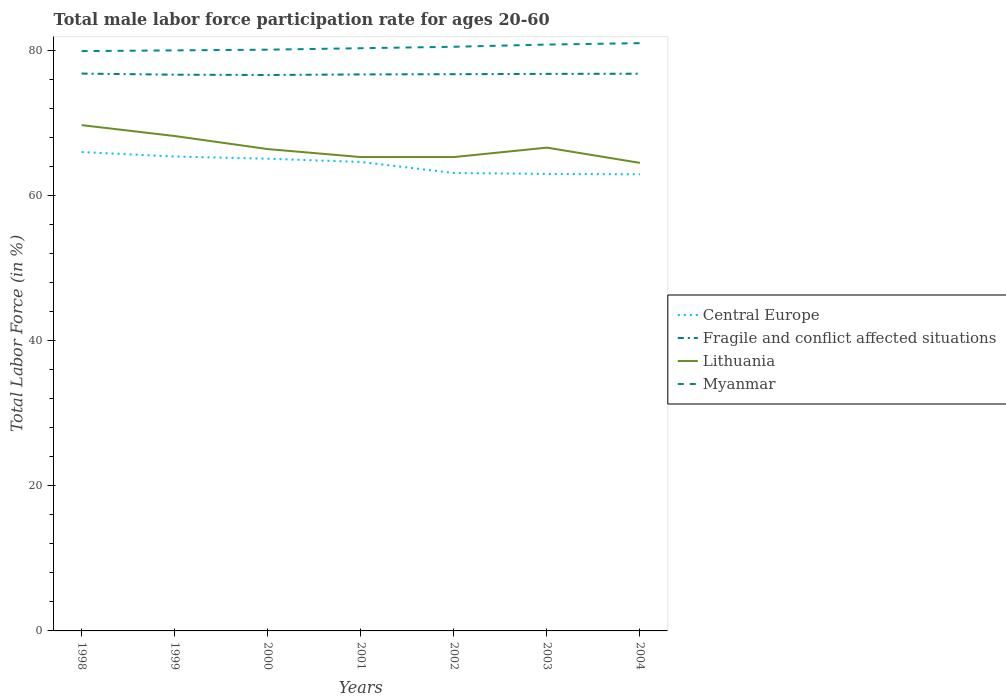Does the line corresponding to Myanmar intersect with the line corresponding to Lithuania?
Make the answer very short. No. Is the number of lines equal to the number of legend labels?
Provide a succinct answer. Yes. Across all years, what is the maximum male labor force participation rate in Lithuania?
Offer a terse response. 64.5. In which year was the male labor force participation rate in Lithuania maximum?
Your answer should be very brief. 2004. What is the total male labor force participation rate in Central Europe in the graph?
Ensure brevity in your answer.  0.75. What is the difference between the highest and the second highest male labor force participation rate in Lithuania?
Make the answer very short. 5.2. What is the difference between the highest and the lowest male labor force participation rate in Fragile and conflict affected situations?
Your response must be concise. 4. Are the values on the major ticks of Y-axis written in scientific E-notation?
Your answer should be very brief. No. Does the graph contain any zero values?
Provide a succinct answer. No. Does the graph contain grids?
Ensure brevity in your answer.  No. Where does the legend appear in the graph?
Provide a short and direct response. Center right. How many legend labels are there?
Your answer should be compact. 4. What is the title of the graph?
Offer a very short reply. Total male labor force participation rate for ages 20-60. What is the label or title of the X-axis?
Offer a terse response. Years. What is the label or title of the Y-axis?
Your response must be concise. Total Labor Force (in %). What is the Total Labor Force (in %) of Central Europe in 1998?
Provide a short and direct response. 65.99. What is the Total Labor Force (in %) of Fragile and conflict affected situations in 1998?
Offer a very short reply. 76.81. What is the Total Labor Force (in %) in Lithuania in 1998?
Keep it short and to the point. 69.7. What is the Total Labor Force (in %) in Myanmar in 1998?
Your answer should be compact. 79.9. What is the Total Labor Force (in %) of Central Europe in 1999?
Your answer should be compact. 65.37. What is the Total Labor Force (in %) of Fragile and conflict affected situations in 1999?
Make the answer very short. 76.65. What is the Total Labor Force (in %) in Lithuania in 1999?
Your response must be concise. 68.2. What is the Total Labor Force (in %) in Central Europe in 2000?
Your answer should be very brief. 65.07. What is the Total Labor Force (in %) in Fragile and conflict affected situations in 2000?
Provide a succinct answer. 76.61. What is the Total Labor Force (in %) of Lithuania in 2000?
Your response must be concise. 66.4. What is the Total Labor Force (in %) of Myanmar in 2000?
Your response must be concise. 80.1. What is the Total Labor Force (in %) of Central Europe in 2001?
Provide a short and direct response. 64.62. What is the Total Labor Force (in %) in Fragile and conflict affected situations in 2001?
Ensure brevity in your answer.  76.69. What is the Total Labor Force (in %) in Lithuania in 2001?
Make the answer very short. 65.3. What is the Total Labor Force (in %) in Myanmar in 2001?
Give a very brief answer. 80.3. What is the Total Labor Force (in %) of Central Europe in 2002?
Provide a succinct answer. 63.11. What is the Total Labor Force (in %) of Fragile and conflict affected situations in 2002?
Offer a very short reply. 76.72. What is the Total Labor Force (in %) of Lithuania in 2002?
Your answer should be compact. 65.3. What is the Total Labor Force (in %) in Myanmar in 2002?
Ensure brevity in your answer.  80.5. What is the Total Labor Force (in %) in Central Europe in 2003?
Offer a very short reply. 62.97. What is the Total Labor Force (in %) in Fragile and conflict affected situations in 2003?
Offer a very short reply. 76.76. What is the Total Labor Force (in %) of Lithuania in 2003?
Offer a very short reply. 66.6. What is the Total Labor Force (in %) of Myanmar in 2003?
Offer a very short reply. 80.8. What is the Total Labor Force (in %) in Central Europe in 2004?
Offer a very short reply. 62.93. What is the Total Labor Force (in %) of Fragile and conflict affected situations in 2004?
Your answer should be compact. 76.79. What is the Total Labor Force (in %) of Lithuania in 2004?
Your response must be concise. 64.5. What is the Total Labor Force (in %) of Myanmar in 2004?
Provide a succinct answer. 81. Across all years, what is the maximum Total Labor Force (in %) in Central Europe?
Provide a succinct answer. 65.99. Across all years, what is the maximum Total Labor Force (in %) of Fragile and conflict affected situations?
Your answer should be compact. 76.81. Across all years, what is the maximum Total Labor Force (in %) in Lithuania?
Provide a succinct answer. 69.7. Across all years, what is the maximum Total Labor Force (in %) in Myanmar?
Provide a succinct answer. 81. Across all years, what is the minimum Total Labor Force (in %) in Central Europe?
Offer a terse response. 62.93. Across all years, what is the minimum Total Labor Force (in %) of Fragile and conflict affected situations?
Provide a short and direct response. 76.61. Across all years, what is the minimum Total Labor Force (in %) in Lithuania?
Your answer should be compact. 64.5. Across all years, what is the minimum Total Labor Force (in %) in Myanmar?
Your answer should be very brief. 79.9. What is the total Total Labor Force (in %) of Central Europe in the graph?
Your answer should be compact. 450.07. What is the total Total Labor Force (in %) of Fragile and conflict affected situations in the graph?
Offer a very short reply. 537.03. What is the total Total Labor Force (in %) in Lithuania in the graph?
Provide a succinct answer. 466. What is the total Total Labor Force (in %) in Myanmar in the graph?
Provide a short and direct response. 562.6. What is the difference between the Total Labor Force (in %) of Central Europe in 1998 and that in 1999?
Offer a very short reply. 0.62. What is the difference between the Total Labor Force (in %) of Fragile and conflict affected situations in 1998 and that in 1999?
Offer a terse response. 0.16. What is the difference between the Total Labor Force (in %) in Lithuania in 1998 and that in 1999?
Keep it short and to the point. 1.5. What is the difference between the Total Labor Force (in %) in Central Europe in 1998 and that in 2000?
Make the answer very short. 0.92. What is the difference between the Total Labor Force (in %) of Fragile and conflict affected situations in 1998 and that in 2000?
Keep it short and to the point. 0.2. What is the difference between the Total Labor Force (in %) of Myanmar in 1998 and that in 2000?
Give a very brief answer. -0.2. What is the difference between the Total Labor Force (in %) in Central Europe in 1998 and that in 2001?
Make the answer very short. 1.37. What is the difference between the Total Labor Force (in %) in Fragile and conflict affected situations in 1998 and that in 2001?
Ensure brevity in your answer.  0.12. What is the difference between the Total Labor Force (in %) in Myanmar in 1998 and that in 2001?
Give a very brief answer. -0.4. What is the difference between the Total Labor Force (in %) of Central Europe in 1998 and that in 2002?
Provide a short and direct response. 2.89. What is the difference between the Total Labor Force (in %) in Fragile and conflict affected situations in 1998 and that in 2002?
Keep it short and to the point. 0.09. What is the difference between the Total Labor Force (in %) in Lithuania in 1998 and that in 2002?
Keep it short and to the point. 4.4. What is the difference between the Total Labor Force (in %) of Myanmar in 1998 and that in 2002?
Provide a succinct answer. -0.6. What is the difference between the Total Labor Force (in %) of Central Europe in 1998 and that in 2003?
Provide a short and direct response. 3.02. What is the difference between the Total Labor Force (in %) of Fragile and conflict affected situations in 1998 and that in 2003?
Your answer should be very brief. 0.04. What is the difference between the Total Labor Force (in %) of Lithuania in 1998 and that in 2003?
Give a very brief answer. 3.1. What is the difference between the Total Labor Force (in %) of Myanmar in 1998 and that in 2003?
Keep it short and to the point. -0.9. What is the difference between the Total Labor Force (in %) of Central Europe in 1998 and that in 2004?
Provide a short and direct response. 3.07. What is the difference between the Total Labor Force (in %) in Fragile and conflict affected situations in 1998 and that in 2004?
Provide a succinct answer. 0.02. What is the difference between the Total Labor Force (in %) of Lithuania in 1998 and that in 2004?
Give a very brief answer. 5.2. What is the difference between the Total Labor Force (in %) of Myanmar in 1998 and that in 2004?
Your answer should be compact. -1.1. What is the difference between the Total Labor Force (in %) in Central Europe in 1999 and that in 2000?
Offer a very short reply. 0.3. What is the difference between the Total Labor Force (in %) in Fragile and conflict affected situations in 1999 and that in 2000?
Keep it short and to the point. 0.04. What is the difference between the Total Labor Force (in %) in Lithuania in 1999 and that in 2000?
Ensure brevity in your answer.  1.8. What is the difference between the Total Labor Force (in %) in Central Europe in 1999 and that in 2001?
Your answer should be compact. 0.75. What is the difference between the Total Labor Force (in %) in Fragile and conflict affected situations in 1999 and that in 2001?
Make the answer very short. -0.04. What is the difference between the Total Labor Force (in %) in Central Europe in 1999 and that in 2002?
Provide a succinct answer. 2.27. What is the difference between the Total Labor Force (in %) in Fragile and conflict affected situations in 1999 and that in 2002?
Keep it short and to the point. -0.07. What is the difference between the Total Labor Force (in %) in Central Europe in 1999 and that in 2003?
Give a very brief answer. 2.4. What is the difference between the Total Labor Force (in %) in Fragile and conflict affected situations in 1999 and that in 2003?
Give a very brief answer. -0.11. What is the difference between the Total Labor Force (in %) of Lithuania in 1999 and that in 2003?
Give a very brief answer. 1.6. What is the difference between the Total Labor Force (in %) in Central Europe in 1999 and that in 2004?
Make the answer very short. 2.45. What is the difference between the Total Labor Force (in %) of Fragile and conflict affected situations in 1999 and that in 2004?
Your response must be concise. -0.14. What is the difference between the Total Labor Force (in %) of Myanmar in 1999 and that in 2004?
Provide a short and direct response. -1. What is the difference between the Total Labor Force (in %) in Central Europe in 2000 and that in 2001?
Your answer should be very brief. 0.45. What is the difference between the Total Labor Force (in %) in Fragile and conflict affected situations in 2000 and that in 2001?
Keep it short and to the point. -0.08. What is the difference between the Total Labor Force (in %) in Central Europe in 2000 and that in 2002?
Provide a short and direct response. 1.97. What is the difference between the Total Labor Force (in %) in Fragile and conflict affected situations in 2000 and that in 2002?
Your answer should be compact. -0.11. What is the difference between the Total Labor Force (in %) in Lithuania in 2000 and that in 2002?
Offer a terse response. 1.1. What is the difference between the Total Labor Force (in %) in Myanmar in 2000 and that in 2002?
Offer a terse response. -0.4. What is the difference between the Total Labor Force (in %) in Central Europe in 2000 and that in 2003?
Give a very brief answer. 2.1. What is the difference between the Total Labor Force (in %) in Fragile and conflict affected situations in 2000 and that in 2003?
Offer a very short reply. -0.15. What is the difference between the Total Labor Force (in %) of Lithuania in 2000 and that in 2003?
Offer a terse response. -0.2. What is the difference between the Total Labor Force (in %) of Central Europe in 2000 and that in 2004?
Make the answer very short. 2.15. What is the difference between the Total Labor Force (in %) in Fragile and conflict affected situations in 2000 and that in 2004?
Keep it short and to the point. -0.18. What is the difference between the Total Labor Force (in %) in Central Europe in 2001 and that in 2002?
Keep it short and to the point. 1.52. What is the difference between the Total Labor Force (in %) in Fragile and conflict affected situations in 2001 and that in 2002?
Your response must be concise. -0.03. What is the difference between the Total Labor Force (in %) of Myanmar in 2001 and that in 2002?
Your response must be concise. -0.2. What is the difference between the Total Labor Force (in %) in Central Europe in 2001 and that in 2003?
Offer a very short reply. 1.65. What is the difference between the Total Labor Force (in %) of Fragile and conflict affected situations in 2001 and that in 2003?
Your answer should be compact. -0.08. What is the difference between the Total Labor Force (in %) of Lithuania in 2001 and that in 2003?
Your answer should be very brief. -1.3. What is the difference between the Total Labor Force (in %) of Myanmar in 2001 and that in 2003?
Keep it short and to the point. -0.5. What is the difference between the Total Labor Force (in %) in Central Europe in 2001 and that in 2004?
Keep it short and to the point. 1.7. What is the difference between the Total Labor Force (in %) of Fragile and conflict affected situations in 2001 and that in 2004?
Keep it short and to the point. -0.1. What is the difference between the Total Labor Force (in %) in Lithuania in 2001 and that in 2004?
Provide a short and direct response. 0.8. What is the difference between the Total Labor Force (in %) of Myanmar in 2001 and that in 2004?
Offer a very short reply. -0.7. What is the difference between the Total Labor Force (in %) in Central Europe in 2002 and that in 2003?
Keep it short and to the point. 0.13. What is the difference between the Total Labor Force (in %) of Fragile and conflict affected situations in 2002 and that in 2003?
Provide a succinct answer. -0.05. What is the difference between the Total Labor Force (in %) in Myanmar in 2002 and that in 2003?
Your answer should be very brief. -0.3. What is the difference between the Total Labor Force (in %) in Central Europe in 2002 and that in 2004?
Keep it short and to the point. 0.18. What is the difference between the Total Labor Force (in %) in Fragile and conflict affected situations in 2002 and that in 2004?
Your response must be concise. -0.07. What is the difference between the Total Labor Force (in %) of Myanmar in 2002 and that in 2004?
Offer a very short reply. -0.5. What is the difference between the Total Labor Force (in %) of Central Europe in 2003 and that in 2004?
Offer a very short reply. 0.05. What is the difference between the Total Labor Force (in %) in Fragile and conflict affected situations in 2003 and that in 2004?
Ensure brevity in your answer.  -0.02. What is the difference between the Total Labor Force (in %) of Central Europe in 1998 and the Total Labor Force (in %) of Fragile and conflict affected situations in 1999?
Give a very brief answer. -10.66. What is the difference between the Total Labor Force (in %) of Central Europe in 1998 and the Total Labor Force (in %) of Lithuania in 1999?
Ensure brevity in your answer.  -2.21. What is the difference between the Total Labor Force (in %) in Central Europe in 1998 and the Total Labor Force (in %) in Myanmar in 1999?
Make the answer very short. -14.01. What is the difference between the Total Labor Force (in %) of Fragile and conflict affected situations in 1998 and the Total Labor Force (in %) of Lithuania in 1999?
Your answer should be compact. 8.61. What is the difference between the Total Labor Force (in %) of Fragile and conflict affected situations in 1998 and the Total Labor Force (in %) of Myanmar in 1999?
Offer a very short reply. -3.19. What is the difference between the Total Labor Force (in %) in Lithuania in 1998 and the Total Labor Force (in %) in Myanmar in 1999?
Your response must be concise. -10.3. What is the difference between the Total Labor Force (in %) in Central Europe in 1998 and the Total Labor Force (in %) in Fragile and conflict affected situations in 2000?
Provide a succinct answer. -10.62. What is the difference between the Total Labor Force (in %) in Central Europe in 1998 and the Total Labor Force (in %) in Lithuania in 2000?
Provide a succinct answer. -0.41. What is the difference between the Total Labor Force (in %) of Central Europe in 1998 and the Total Labor Force (in %) of Myanmar in 2000?
Offer a very short reply. -14.11. What is the difference between the Total Labor Force (in %) of Fragile and conflict affected situations in 1998 and the Total Labor Force (in %) of Lithuania in 2000?
Offer a very short reply. 10.41. What is the difference between the Total Labor Force (in %) in Fragile and conflict affected situations in 1998 and the Total Labor Force (in %) in Myanmar in 2000?
Your answer should be very brief. -3.29. What is the difference between the Total Labor Force (in %) in Central Europe in 1998 and the Total Labor Force (in %) in Fragile and conflict affected situations in 2001?
Provide a short and direct response. -10.69. What is the difference between the Total Labor Force (in %) in Central Europe in 1998 and the Total Labor Force (in %) in Lithuania in 2001?
Your answer should be compact. 0.69. What is the difference between the Total Labor Force (in %) in Central Europe in 1998 and the Total Labor Force (in %) in Myanmar in 2001?
Make the answer very short. -14.3. What is the difference between the Total Labor Force (in %) of Fragile and conflict affected situations in 1998 and the Total Labor Force (in %) of Lithuania in 2001?
Your response must be concise. 11.51. What is the difference between the Total Labor Force (in %) in Fragile and conflict affected situations in 1998 and the Total Labor Force (in %) in Myanmar in 2001?
Make the answer very short. -3.49. What is the difference between the Total Labor Force (in %) in Central Europe in 1998 and the Total Labor Force (in %) in Fragile and conflict affected situations in 2002?
Your answer should be very brief. -10.72. What is the difference between the Total Labor Force (in %) of Central Europe in 1998 and the Total Labor Force (in %) of Lithuania in 2002?
Keep it short and to the point. 0.69. What is the difference between the Total Labor Force (in %) in Central Europe in 1998 and the Total Labor Force (in %) in Myanmar in 2002?
Provide a short and direct response. -14.51. What is the difference between the Total Labor Force (in %) of Fragile and conflict affected situations in 1998 and the Total Labor Force (in %) of Lithuania in 2002?
Your answer should be very brief. 11.51. What is the difference between the Total Labor Force (in %) of Fragile and conflict affected situations in 1998 and the Total Labor Force (in %) of Myanmar in 2002?
Your answer should be compact. -3.69. What is the difference between the Total Labor Force (in %) in Central Europe in 1998 and the Total Labor Force (in %) in Fragile and conflict affected situations in 2003?
Offer a terse response. -10.77. What is the difference between the Total Labor Force (in %) of Central Europe in 1998 and the Total Labor Force (in %) of Lithuania in 2003?
Provide a succinct answer. -0.6. What is the difference between the Total Labor Force (in %) in Central Europe in 1998 and the Total Labor Force (in %) in Myanmar in 2003?
Offer a terse response. -14.8. What is the difference between the Total Labor Force (in %) in Fragile and conflict affected situations in 1998 and the Total Labor Force (in %) in Lithuania in 2003?
Offer a very short reply. 10.21. What is the difference between the Total Labor Force (in %) in Fragile and conflict affected situations in 1998 and the Total Labor Force (in %) in Myanmar in 2003?
Keep it short and to the point. -3.99. What is the difference between the Total Labor Force (in %) in Lithuania in 1998 and the Total Labor Force (in %) in Myanmar in 2003?
Provide a short and direct response. -11.1. What is the difference between the Total Labor Force (in %) of Central Europe in 1998 and the Total Labor Force (in %) of Fragile and conflict affected situations in 2004?
Provide a succinct answer. -10.79. What is the difference between the Total Labor Force (in %) in Central Europe in 1998 and the Total Labor Force (in %) in Lithuania in 2004?
Provide a short and direct response. 1.5. What is the difference between the Total Labor Force (in %) of Central Europe in 1998 and the Total Labor Force (in %) of Myanmar in 2004?
Ensure brevity in your answer.  -15.01. What is the difference between the Total Labor Force (in %) in Fragile and conflict affected situations in 1998 and the Total Labor Force (in %) in Lithuania in 2004?
Give a very brief answer. 12.31. What is the difference between the Total Labor Force (in %) in Fragile and conflict affected situations in 1998 and the Total Labor Force (in %) in Myanmar in 2004?
Offer a terse response. -4.19. What is the difference between the Total Labor Force (in %) of Lithuania in 1998 and the Total Labor Force (in %) of Myanmar in 2004?
Provide a succinct answer. -11.3. What is the difference between the Total Labor Force (in %) in Central Europe in 1999 and the Total Labor Force (in %) in Fragile and conflict affected situations in 2000?
Your answer should be very brief. -11.24. What is the difference between the Total Labor Force (in %) in Central Europe in 1999 and the Total Labor Force (in %) in Lithuania in 2000?
Your answer should be very brief. -1.02. What is the difference between the Total Labor Force (in %) of Central Europe in 1999 and the Total Labor Force (in %) of Myanmar in 2000?
Make the answer very short. -14.72. What is the difference between the Total Labor Force (in %) of Fragile and conflict affected situations in 1999 and the Total Labor Force (in %) of Lithuania in 2000?
Your answer should be very brief. 10.25. What is the difference between the Total Labor Force (in %) of Fragile and conflict affected situations in 1999 and the Total Labor Force (in %) of Myanmar in 2000?
Make the answer very short. -3.45. What is the difference between the Total Labor Force (in %) of Central Europe in 1999 and the Total Labor Force (in %) of Fragile and conflict affected situations in 2001?
Provide a short and direct response. -11.31. What is the difference between the Total Labor Force (in %) in Central Europe in 1999 and the Total Labor Force (in %) in Lithuania in 2001?
Your answer should be compact. 0.07. What is the difference between the Total Labor Force (in %) in Central Europe in 1999 and the Total Labor Force (in %) in Myanmar in 2001?
Give a very brief answer. -14.93. What is the difference between the Total Labor Force (in %) in Fragile and conflict affected situations in 1999 and the Total Labor Force (in %) in Lithuania in 2001?
Provide a short and direct response. 11.35. What is the difference between the Total Labor Force (in %) in Fragile and conflict affected situations in 1999 and the Total Labor Force (in %) in Myanmar in 2001?
Your answer should be very brief. -3.65. What is the difference between the Total Labor Force (in %) of Central Europe in 1999 and the Total Labor Force (in %) of Fragile and conflict affected situations in 2002?
Your response must be concise. -11.34. What is the difference between the Total Labor Force (in %) of Central Europe in 1999 and the Total Labor Force (in %) of Lithuania in 2002?
Ensure brevity in your answer.  0.07. What is the difference between the Total Labor Force (in %) of Central Europe in 1999 and the Total Labor Force (in %) of Myanmar in 2002?
Offer a terse response. -15.12. What is the difference between the Total Labor Force (in %) in Fragile and conflict affected situations in 1999 and the Total Labor Force (in %) in Lithuania in 2002?
Keep it short and to the point. 11.35. What is the difference between the Total Labor Force (in %) of Fragile and conflict affected situations in 1999 and the Total Labor Force (in %) of Myanmar in 2002?
Keep it short and to the point. -3.85. What is the difference between the Total Labor Force (in %) in Lithuania in 1999 and the Total Labor Force (in %) in Myanmar in 2002?
Ensure brevity in your answer.  -12.3. What is the difference between the Total Labor Force (in %) of Central Europe in 1999 and the Total Labor Force (in %) of Fragile and conflict affected situations in 2003?
Offer a very short reply. -11.39. What is the difference between the Total Labor Force (in %) in Central Europe in 1999 and the Total Labor Force (in %) in Lithuania in 2003?
Provide a short and direct response. -1.23. What is the difference between the Total Labor Force (in %) in Central Europe in 1999 and the Total Labor Force (in %) in Myanmar in 2003?
Offer a terse response. -15.43. What is the difference between the Total Labor Force (in %) in Fragile and conflict affected situations in 1999 and the Total Labor Force (in %) in Lithuania in 2003?
Your response must be concise. 10.05. What is the difference between the Total Labor Force (in %) in Fragile and conflict affected situations in 1999 and the Total Labor Force (in %) in Myanmar in 2003?
Provide a succinct answer. -4.15. What is the difference between the Total Labor Force (in %) in Lithuania in 1999 and the Total Labor Force (in %) in Myanmar in 2003?
Your answer should be very brief. -12.6. What is the difference between the Total Labor Force (in %) in Central Europe in 1999 and the Total Labor Force (in %) in Fragile and conflict affected situations in 2004?
Offer a terse response. -11.41. What is the difference between the Total Labor Force (in %) of Central Europe in 1999 and the Total Labor Force (in %) of Lithuania in 2004?
Offer a very short reply. 0.88. What is the difference between the Total Labor Force (in %) of Central Europe in 1999 and the Total Labor Force (in %) of Myanmar in 2004?
Make the answer very short. -15.62. What is the difference between the Total Labor Force (in %) of Fragile and conflict affected situations in 1999 and the Total Labor Force (in %) of Lithuania in 2004?
Offer a very short reply. 12.15. What is the difference between the Total Labor Force (in %) in Fragile and conflict affected situations in 1999 and the Total Labor Force (in %) in Myanmar in 2004?
Provide a succinct answer. -4.35. What is the difference between the Total Labor Force (in %) of Central Europe in 2000 and the Total Labor Force (in %) of Fragile and conflict affected situations in 2001?
Provide a succinct answer. -11.61. What is the difference between the Total Labor Force (in %) in Central Europe in 2000 and the Total Labor Force (in %) in Lithuania in 2001?
Ensure brevity in your answer.  -0.23. What is the difference between the Total Labor Force (in %) of Central Europe in 2000 and the Total Labor Force (in %) of Myanmar in 2001?
Keep it short and to the point. -15.23. What is the difference between the Total Labor Force (in %) in Fragile and conflict affected situations in 2000 and the Total Labor Force (in %) in Lithuania in 2001?
Provide a succinct answer. 11.31. What is the difference between the Total Labor Force (in %) of Fragile and conflict affected situations in 2000 and the Total Labor Force (in %) of Myanmar in 2001?
Offer a terse response. -3.69. What is the difference between the Total Labor Force (in %) of Central Europe in 2000 and the Total Labor Force (in %) of Fragile and conflict affected situations in 2002?
Your response must be concise. -11.65. What is the difference between the Total Labor Force (in %) in Central Europe in 2000 and the Total Labor Force (in %) in Lithuania in 2002?
Your response must be concise. -0.23. What is the difference between the Total Labor Force (in %) of Central Europe in 2000 and the Total Labor Force (in %) of Myanmar in 2002?
Your answer should be very brief. -15.43. What is the difference between the Total Labor Force (in %) of Fragile and conflict affected situations in 2000 and the Total Labor Force (in %) of Lithuania in 2002?
Give a very brief answer. 11.31. What is the difference between the Total Labor Force (in %) of Fragile and conflict affected situations in 2000 and the Total Labor Force (in %) of Myanmar in 2002?
Provide a succinct answer. -3.89. What is the difference between the Total Labor Force (in %) in Lithuania in 2000 and the Total Labor Force (in %) in Myanmar in 2002?
Your response must be concise. -14.1. What is the difference between the Total Labor Force (in %) of Central Europe in 2000 and the Total Labor Force (in %) of Fragile and conflict affected situations in 2003?
Provide a short and direct response. -11.69. What is the difference between the Total Labor Force (in %) of Central Europe in 2000 and the Total Labor Force (in %) of Lithuania in 2003?
Offer a very short reply. -1.53. What is the difference between the Total Labor Force (in %) in Central Europe in 2000 and the Total Labor Force (in %) in Myanmar in 2003?
Ensure brevity in your answer.  -15.73. What is the difference between the Total Labor Force (in %) of Fragile and conflict affected situations in 2000 and the Total Labor Force (in %) of Lithuania in 2003?
Your answer should be very brief. 10.01. What is the difference between the Total Labor Force (in %) of Fragile and conflict affected situations in 2000 and the Total Labor Force (in %) of Myanmar in 2003?
Your answer should be compact. -4.19. What is the difference between the Total Labor Force (in %) in Lithuania in 2000 and the Total Labor Force (in %) in Myanmar in 2003?
Provide a short and direct response. -14.4. What is the difference between the Total Labor Force (in %) in Central Europe in 2000 and the Total Labor Force (in %) in Fragile and conflict affected situations in 2004?
Ensure brevity in your answer.  -11.71. What is the difference between the Total Labor Force (in %) of Central Europe in 2000 and the Total Labor Force (in %) of Lithuania in 2004?
Provide a succinct answer. 0.57. What is the difference between the Total Labor Force (in %) in Central Europe in 2000 and the Total Labor Force (in %) in Myanmar in 2004?
Make the answer very short. -15.93. What is the difference between the Total Labor Force (in %) in Fragile and conflict affected situations in 2000 and the Total Labor Force (in %) in Lithuania in 2004?
Provide a short and direct response. 12.11. What is the difference between the Total Labor Force (in %) in Fragile and conflict affected situations in 2000 and the Total Labor Force (in %) in Myanmar in 2004?
Keep it short and to the point. -4.39. What is the difference between the Total Labor Force (in %) of Lithuania in 2000 and the Total Labor Force (in %) of Myanmar in 2004?
Your answer should be compact. -14.6. What is the difference between the Total Labor Force (in %) of Central Europe in 2001 and the Total Labor Force (in %) of Fragile and conflict affected situations in 2002?
Offer a terse response. -12.09. What is the difference between the Total Labor Force (in %) in Central Europe in 2001 and the Total Labor Force (in %) in Lithuania in 2002?
Your response must be concise. -0.68. What is the difference between the Total Labor Force (in %) in Central Europe in 2001 and the Total Labor Force (in %) in Myanmar in 2002?
Keep it short and to the point. -15.88. What is the difference between the Total Labor Force (in %) in Fragile and conflict affected situations in 2001 and the Total Labor Force (in %) in Lithuania in 2002?
Ensure brevity in your answer.  11.39. What is the difference between the Total Labor Force (in %) of Fragile and conflict affected situations in 2001 and the Total Labor Force (in %) of Myanmar in 2002?
Give a very brief answer. -3.81. What is the difference between the Total Labor Force (in %) in Lithuania in 2001 and the Total Labor Force (in %) in Myanmar in 2002?
Offer a very short reply. -15.2. What is the difference between the Total Labor Force (in %) of Central Europe in 2001 and the Total Labor Force (in %) of Fragile and conflict affected situations in 2003?
Provide a succinct answer. -12.14. What is the difference between the Total Labor Force (in %) in Central Europe in 2001 and the Total Labor Force (in %) in Lithuania in 2003?
Your answer should be very brief. -1.98. What is the difference between the Total Labor Force (in %) of Central Europe in 2001 and the Total Labor Force (in %) of Myanmar in 2003?
Provide a succinct answer. -16.18. What is the difference between the Total Labor Force (in %) in Fragile and conflict affected situations in 2001 and the Total Labor Force (in %) in Lithuania in 2003?
Provide a short and direct response. 10.09. What is the difference between the Total Labor Force (in %) in Fragile and conflict affected situations in 2001 and the Total Labor Force (in %) in Myanmar in 2003?
Offer a terse response. -4.11. What is the difference between the Total Labor Force (in %) of Lithuania in 2001 and the Total Labor Force (in %) of Myanmar in 2003?
Make the answer very short. -15.5. What is the difference between the Total Labor Force (in %) of Central Europe in 2001 and the Total Labor Force (in %) of Fragile and conflict affected situations in 2004?
Provide a succinct answer. -12.16. What is the difference between the Total Labor Force (in %) in Central Europe in 2001 and the Total Labor Force (in %) in Lithuania in 2004?
Your response must be concise. 0.12. What is the difference between the Total Labor Force (in %) of Central Europe in 2001 and the Total Labor Force (in %) of Myanmar in 2004?
Your response must be concise. -16.38. What is the difference between the Total Labor Force (in %) of Fragile and conflict affected situations in 2001 and the Total Labor Force (in %) of Lithuania in 2004?
Offer a very short reply. 12.19. What is the difference between the Total Labor Force (in %) in Fragile and conflict affected situations in 2001 and the Total Labor Force (in %) in Myanmar in 2004?
Provide a short and direct response. -4.31. What is the difference between the Total Labor Force (in %) of Lithuania in 2001 and the Total Labor Force (in %) of Myanmar in 2004?
Provide a short and direct response. -15.7. What is the difference between the Total Labor Force (in %) in Central Europe in 2002 and the Total Labor Force (in %) in Fragile and conflict affected situations in 2003?
Ensure brevity in your answer.  -13.66. What is the difference between the Total Labor Force (in %) of Central Europe in 2002 and the Total Labor Force (in %) of Lithuania in 2003?
Provide a succinct answer. -3.49. What is the difference between the Total Labor Force (in %) in Central Europe in 2002 and the Total Labor Force (in %) in Myanmar in 2003?
Provide a short and direct response. -17.69. What is the difference between the Total Labor Force (in %) in Fragile and conflict affected situations in 2002 and the Total Labor Force (in %) in Lithuania in 2003?
Your response must be concise. 10.12. What is the difference between the Total Labor Force (in %) in Fragile and conflict affected situations in 2002 and the Total Labor Force (in %) in Myanmar in 2003?
Provide a short and direct response. -4.08. What is the difference between the Total Labor Force (in %) of Lithuania in 2002 and the Total Labor Force (in %) of Myanmar in 2003?
Offer a terse response. -15.5. What is the difference between the Total Labor Force (in %) of Central Europe in 2002 and the Total Labor Force (in %) of Fragile and conflict affected situations in 2004?
Provide a short and direct response. -13.68. What is the difference between the Total Labor Force (in %) in Central Europe in 2002 and the Total Labor Force (in %) in Lithuania in 2004?
Make the answer very short. -1.39. What is the difference between the Total Labor Force (in %) of Central Europe in 2002 and the Total Labor Force (in %) of Myanmar in 2004?
Ensure brevity in your answer.  -17.89. What is the difference between the Total Labor Force (in %) of Fragile and conflict affected situations in 2002 and the Total Labor Force (in %) of Lithuania in 2004?
Make the answer very short. 12.22. What is the difference between the Total Labor Force (in %) in Fragile and conflict affected situations in 2002 and the Total Labor Force (in %) in Myanmar in 2004?
Provide a short and direct response. -4.28. What is the difference between the Total Labor Force (in %) of Lithuania in 2002 and the Total Labor Force (in %) of Myanmar in 2004?
Your answer should be compact. -15.7. What is the difference between the Total Labor Force (in %) of Central Europe in 2003 and the Total Labor Force (in %) of Fragile and conflict affected situations in 2004?
Make the answer very short. -13.81. What is the difference between the Total Labor Force (in %) of Central Europe in 2003 and the Total Labor Force (in %) of Lithuania in 2004?
Provide a short and direct response. -1.53. What is the difference between the Total Labor Force (in %) of Central Europe in 2003 and the Total Labor Force (in %) of Myanmar in 2004?
Ensure brevity in your answer.  -18.03. What is the difference between the Total Labor Force (in %) of Fragile and conflict affected situations in 2003 and the Total Labor Force (in %) of Lithuania in 2004?
Offer a terse response. 12.26. What is the difference between the Total Labor Force (in %) of Fragile and conflict affected situations in 2003 and the Total Labor Force (in %) of Myanmar in 2004?
Your answer should be compact. -4.24. What is the difference between the Total Labor Force (in %) in Lithuania in 2003 and the Total Labor Force (in %) in Myanmar in 2004?
Keep it short and to the point. -14.4. What is the average Total Labor Force (in %) of Central Europe per year?
Ensure brevity in your answer.  64.3. What is the average Total Labor Force (in %) in Fragile and conflict affected situations per year?
Keep it short and to the point. 76.72. What is the average Total Labor Force (in %) in Lithuania per year?
Give a very brief answer. 66.57. What is the average Total Labor Force (in %) of Myanmar per year?
Your response must be concise. 80.37. In the year 1998, what is the difference between the Total Labor Force (in %) of Central Europe and Total Labor Force (in %) of Fragile and conflict affected situations?
Provide a succinct answer. -10.81. In the year 1998, what is the difference between the Total Labor Force (in %) in Central Europe and Total Labor Force (in %) in Lithuania?
Ensure brevity in your answer.  -3.71. In the year 1998, what is the difference between the Total Labor Force (in %) in Central Europe and Total Labor Force (in %) in Myanmar?
Your answer should be very brief. -13.9. In the year 1998, what is the difference between the Total Labor Force (in %) in Fragile and conflict affected situations and Total Labor Force (in %) in Lithuania?
Offer a very short reply. 7.11. In the year 1998, what is the difference between the Total Labor Force (in %) in Fragile and conflict affected situations and Total Labor Force (in %) in Myanmar?
Your answer should be very brief. -3.09. In the year 1999, what is the difference between the Total Labor Force (in %) of Central Europe and Total Labor Force (in %) of Fragile and conflict affected situations?
Make the answer very short. -11.28. In the year 1999, what is the difference between the Total Labor Force (in %) in Central Europe and Total Labor Force (in %) in Lithuania?
Ensure brevity in your answer.  -2.83. In the year 1999, what is the difference between the Total Labor Force (in %) of Central Europe and Total Labor Force (in %) of Myanmar?
Your answer should be compact. -14.62. In the year 1999, what is the difference between the Total Labor Force (in %) in Fragile and conflict affected situations and Total Labor Force (in %) in Lithuania?
Give a very brief answer. 8.45. In the year 1999, what is the difference between the Total Labor Force (in %) in Fragile and conflict affected situations and Total Labor Force (in %) in Myanmar?
Offer a very short reply. -3.35. In the year 2000, what is the difference between the Total Labor Force (in %) in Central Europe and Total Labor Force (in %) in Fragile and conflict affected situations?
Your response must be concise. -11.54. In the year 2000, what is the difference between the Total Labor Force (in %) of Central Europe and Total Labor Force (in %) of Lithuania?
Give a very brief answer. -1.33. In the year 2000, what is the difference between the Total Labor Force (in %) of Central Europe and Total Labor Force (in %) of Myanmar?
Make the answer very short. -15.03. In the year 2000, what is the difference between the Total Labor Force (in %) of Fragile and conflict affected situations and Total Labor Force (in %) of Lithuania?
Keep it short and to the point. 10.21. In the year 2000, what is the difference between the Total Labor Force (in %) in Fragile and conflict affected situations and Total Labor Force (in %) in Myanmar?
Provide a succinct answer. -3.49. In the year 2000, what is the difference between the Total Labor Force (in %) of Lithuania and Total Labor Force (in %) of Myanmar?
Ensure brevity in your answer.  -13.7. In the year 2001, what is the difference between the Total Labor Force (in %) in Central Europe and Total Labor Force (in %) in Fragile and conflict affected situations?
Keep it short and to the point. -12.06. In the year 2001, what is the difference between the Total Labor Force (in %) of Central Europe and Total Labor Force (in %) of Lithuania?
Your answer should be compact. -0.68. In the year 2001, what is the difference between the Total Labor Force (in %) in Central Europe and Total Labor Force (in %) in Myanmar?
Provide a short and direct response. -15.68. In the year 2001, what is the difference between the Total Labor Force (in %) of Fragile and conflict affected situations and Total Labor Force (in %) of Lithuania?
Your answer should be very brief. 11.39. In the year 2001, what is the difference between the Total Labor Force (in %) in Fragile and conflict affected situations and Total Labor Force (in %) in Myanmar?
Ensure brevity in your answer.  -3.61. In the year 2001, what is the difference between the Total Labor Force (in %) of Lithuania and Total Labor Force (in %) of Myanmar?
Offer a very short reply. -15. In the year 2002, what is the difference between the Total Labor Force (in %) of Central Europe and Total Labor Force (in %) of Fragile and conflict affected situations?
Your answer should be compact. -13.61. In the year 2002, what is the difference between the Total Labor Force (in %) of Central Europe and Total Labor Force (in %) of Lithuania?
Your answer should be compact. -2.19. In the year 2002, what is the difference between the Total Labor Force (in %) in Central Europe and Total Labor Force (in %) in Myanmar?
Provide a short and direct response. -17.39. In the year 2002, what is the difference between the Total Labor Force (in %) in Fragile and conflict affected situations and Total Labor Force (in %) in Lithuania?
Ensure brevity in your answer.  11.42. In the year 2002, what is the difference between the Total Labor Force (in %) of Fragile and conflict affected situations and Total Labor Force (in %) of Myanmar?
Provide a succinct answer. -3.78. In the year 2002, what is the difference between the Total Labor Force (in %) in Lithuania and Total Labor Force (in %) in Myanmar?
Your answer should be very brief. -15.2. In the year 2003, what is the difference between the Total Labor Force (in %) in Central Europe and Total Labor Force (in %) in Fragile and conflict affected situations?
Your answer should be compact. -13.79. In the year 2003, what is the difference between the Total Labor Force (in %) in Central Europe and Total Labor Force (in %) in Lithuania?
Your answer should be very brief. -3.63. In the year 2003, what is the difference between the Total Labor Force (in %) of Central Europe and Total Labor Force (in %) of Myanmar?
Provide a short and direct response. -17.83. In the year 2003, what is the difference between the Total Labor Force (in %) in Fragile and conflict affected situations and Total Labor Force (in %) in Lithuania?
Ensure brevity in your answer.  10.16. In the year 2003, what is the difference between the Total Labor Force (in %) of Fragile and conflict affected situations and Total Labor Force (in %) of Myanmar?
Keep it short and to the point. -4.04. In the year 2004, what is the difference between the Total Labor Force (in %) of Central Europe and Total Labor Force (in %) of Fragile and conflict affected situations?
Give a very brief answer. -13.86. In the year 2004, what is the difference between the Total Labor Force (in %) in Central Europe and Total Labor Force (in %) in Lithuania?
Your answer should be compact. -1.57. In the year 2004, what is the difference between the Total Labor Force (in %) in Central Europe and Total Labor Force (in %) in Myanmar?
Ensure brevity in your answer.  -18.07. In the year 2004, what is the difference between the Total Labor Force (in %) of Fragile and conflict affected situations and Total Labor Force (in %) of Lithuania?
Your response must be concise. 12.29. In the year 2004, what is the difference between the Total Labor Force (in %) of Fragile and conflict affected situations and Total Labor Force (in %) of Myanmar?
Provide a short and direct response. -4.21. In the year 2004, what is the difference between the Total Labor Force (in %) in Lithuania and Total Labor Force (in %) in Myanmar?
Give a very brief answer. -16.5. What is the ratio of the Total Labor Force (in %) in Central Europe in 1998 to that in 1999?
Give a very brief answer. 1.01. What is the ratio of the Total Labor Force (in %) of Central Europe in 1998 to that in 2000?
Your answer should be compact. 1.01. What is the ratio of the Total Labor Force (in %) of Lithuania in 1998 to that in 2000?
Offer a very short reply. 1.05. What is the ratio of the Total Labor Force (in %) in Central Europe in 1998 to that in 2001?
Your answer should be compact. 1.02. What is the ratio of the Total Labor Force (in %) of Lithuania in 1998 to that in 2001?
Ensure brevity in your answer.  1.07. What is the ratio of the Total Labor Force (in %) in Central Europe in 1998 to that in 2002?
Keep it short and to the point. 1.05. What is the ratio of the Total Labor Force (in %) in Lithuania in 1998 to that in 2002?
Your answer should be very brief. 1.07. What is the ratio of the Total Labor Force (in %) in Myanmar in 1998 to that in 2002?
Your response must be concise. 0.99. What is the ratio of the Total Labor Force (in %) in Central Europe in 1998 to that in 2003?
Offer a very short reply. 1.05. What is the ratio of the Total Labor Force (in %) in Fragile and conflict affected situations in 1998 to that in 2003?
Offer a very short reply. 1. What is the ratio of the Total Labor Force (in %) in Lithuania in 1998 to that in 2003?
Your answer should be very brief. 1.05. What is the ratio of the Total Labor Force (in %) in Myanmar in 1998 to that in 2003?
Ensure brevity in your answer.  0.99. What is the ratio of the Total Labor Force (in %) in Central Europe in 1998 to that in 2004?
Keep it short and to the point. 1.05. What is the ratio of the Total Labor Force (in %) of Lithuania in 1998 to that in 2004?
Provide a succinct answer. 1.08. What is the ratio of the Total Labor Force (in %) in Myanmar in 1998 to that in 2004?
Your answer should be compact. 0.99. What is the ratio of the Total Labor Force (in %) in Lithuania in 1999 to that in 2000?
Your answer should be very brief. 1.03. What is the ratio of the Total Labor Force (in %) in Myanmar in 1999 to that in 2000?
Provide a succinct answer. 1. What is the ratio of the Total Labor Force (in %) in Central Europe in 1999 to that in 2001?
Make the answer very short. 1.01. What is the ratio of the Total Labor Force (in %) in Fragile and conflict affected situations in 1999 to that in 2001?
Offer a very short reply. 1. What is the ratio of the Total Labor Force (in %) in Lithuania in 1999 to that in 2001?
Give a very brief answer. 1.04. What is the ratio of the Total Labor Force (in %) of Myanmar in 1999 to that in 2001?
Offer a terse response. 1. What is the ratio of the Total Labor Force (in %) of Central Europe in 1999 to that in 2002?
Offer a terse response. 1.04. What is the ratio of the Total Labor Force (in %) in Lithuania in 1999 to that in 2002?
Give a very brief answer. 1.04. What is the ratio of the Total Labor Force (in %) of Central Europe in 1999 to that in 2003?
Ensure brevity in your answer.  1.04. What is the ratio of the Total Labor Force (in %) in Lithuania in 1999 to that in 2003?
Provide a succinct answer. 1.02. What is the ratio of the Total Labor Force (in %) of Central Europe in 1999 to that in 2004?
Ensure brevity in your answer.  1.04. What is the ratio of the Total Labor Force (in %) of Fragile and conflict affected situations in 1999 to that in 2004?
Provide a succinct answer. 1. What is the ratio of the Total Labor Force (in %) of Lithuania in 1999 to that in 2004?
Your answer should be compact. 1.06. What is the ratio of the Total Labor Force (in %) in Myanmar in 1999 to that in 2004?
Offer a terse response. 0.99. What is the ratio of the Total Labor Force (in %) of Fragile and conflict affected situations in 2000 to that in 2001?
Provide a short and direct response. 1. What is the ratio of the Total Labor Force (in %) in Lithuania in 2000 to that in 2001?
Keep it short and to the point. 1.02. What is the ratio of the Total Labor Force (in %) in Myanmar in 2000 to that in 2001?
Your response must be concise. 1. What is the ratio of the Total Labor Force (in %) of Central Europe in 2000 to that in 2002?
Provide a succinct answer. 1.03. What is the ratio of the Total Labor Force (in %) of Fragile and conflict affected situations in 2000 to that in 2002?
Offer a very short reply. 1. What is the ratio of the Total Labor Force (in %) in Lithuania in 2000 to that in 2002?
Provide a succinct answer. 1.02. What is the ratio of the Total Labor Force (in %) of Myanmar in 2000 to that in 2002?
Provide a succinct answer. 0.99. What is the ratio of the Total Labor Force (in %) in Central Europe in 2000 to that in 2003?
Your answer should be compact. 1.03. What is the ratio of the Total Labor Force (in %) of Fragile and conflict affected situations in 2000 to that in 2003?
Your answer should be very brief. 1. What is the ratio of the Total Labor Force (in %) of Central Europe in 2000 to that in 2004?
Make the answer very short. 1.03. What is the ratio of the Total Labor Force (in %) in Lithuania in 2000 to that in 2004?
Offer a very short reply. 1.03. What is the ratio of the Total Labor Force (in %) in Myanmar in 2000 to that in 2004?
Keep it short and to the point. 0.99. What is the ratio of the Total Labor Force (in %) in Central Europe in 2001 to that in 2002?
Give a very brief answer. 1.02. What is the ratio of the Total Labor Force (in %) of Fragile and conflict affected situations in 2001 to that in 2002?
Your answer should be compact. 1. What is the ratio of the Total Labor Force (in %) in Lithuania in 2001 to that in 2002?
Provide a succinct answer. 1. What is the ratio of the Total Labor Force (in %) of Myanmar in 2001 to that in 2002?
Give a very brief answer. 1. What is the ratio of the Total Labor Force (in %) in Central Europe in 2001 to that in 2003?
Make the answer very short. 1.03. What is the ratio of the Total Labor Force (in %) of Lithuania in 2001 to that in 2003?
Offer a terse response. 0.98. What is the ratio of the Total Labor Force (in %) of Myanmar in 2001 to that in 2003?
Your response must be concise. 0.99. What is the ratio of the Total Labor Force (in %) of Lithuania in 2001 to that in 2004?
Offer a terse response. 1.01. What is the ratio of the Total Labor Force (in %) in Fragile and conflict affected situations in 2002 to that in 2003?
Offer a very short reply. 1. What is the ratio of the Total Labor Force (in %) in Lithuania in 2002 to that in 2003?
Offer a very short reply. 0.98. What is the ratio of the Total Labor Force (in %) of Myanmar in 2002 to that in 2003?
Provide a succinct answer. 1. What is the ratio of the Total Labor Force (in %) in Central Europe in 2002 to that in 2004?
Give a very brief answer. 1. What is the ratio of the Total Labor Force (in %) in Fragile and conflict affected situations in 2002 to that in 2004?
Provide a succinct answer. 1. What is the ratio of the Total Labor Force (in %) in Lithuania in 2002 to that in 2004?
Your response must be concise. 1.01. What is the ratio of the Total Labor Force (in %) of Fragile and conflict affected situations in 2003 to that in 2004?
Your response must be concise. 1. What is the ratio of the Total Labor Force (in %) in Lithuania in 2003 to that in 2004?
Offer a terse response. 1.03. What is the difference between the highest and the second highest Total Labor Force (in %) of Central Europe?
Keep it short and to the point. 0.62. What is the difference between the highest and the second highest Total Labor Force (in %) of Fragile and conflict affected situations?
Make the answer very short. 0.02. What is the difference between the highest and the second highest Total Labor Force (in %) of Lithuania?
Provide a succinct answer. 1.5. What is the difference between the highest and the lowest Total Labor Force (in %) of Central Europe?
Offer a very short reply. 3.07. What is the difference between the highest and the lowest Total Labor Force (in %) of Fragile and conflict affected situations?
Your answer should be compact. 0.2. What is the difference between the highest and the lowest Total Labor Force (in %) in Lithuania?
Ensure brevity in your answer.  5.2. What is the difference between the highest and the lowest Total Labor Force (in %) in Myanmar?
Offer a very short reply. 1.1. 